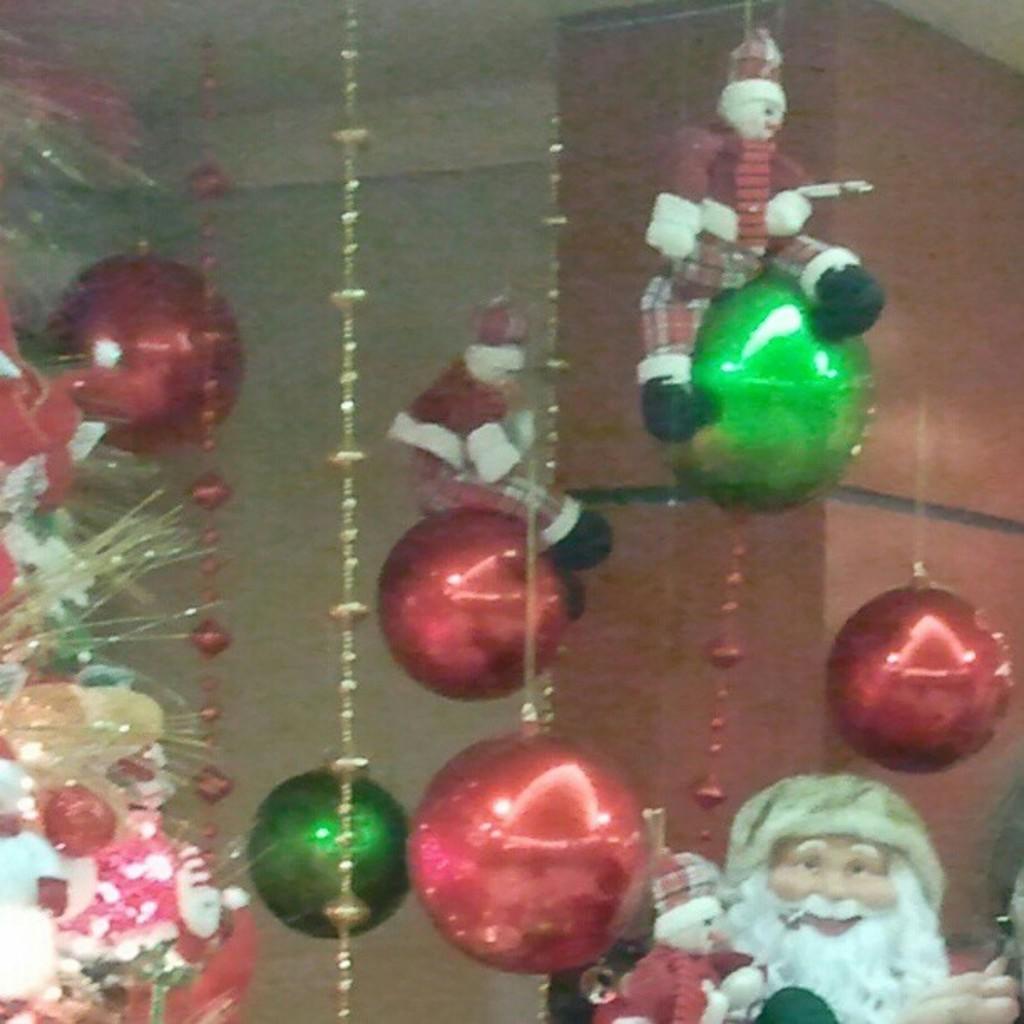Can you describe this image briefly? In this picture I can see few soft toys hanging and few decorative balls and a Santa Claus statue and few flowers on the side. 